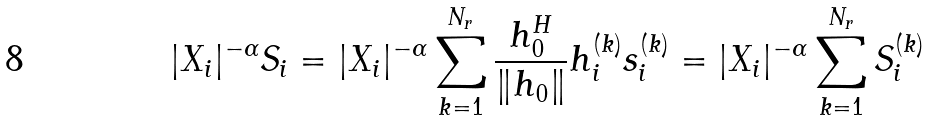<formula> <loc_0><loc_0><loc_500><loc_500>| X _ { i } | ^ { - \alpha } S _ { i } = | X _ { i } | ^ { - \alpha } \sum ^ { N _ { r } } _ { k = 1 } \frac { h _ { 0 } ^ { H } } { \| h _ { 0 } \| } h ^ { ( k ) } _ { i } s ^ { ( k ) } _ { i } = | X _ { i } | ^ { - \alpha } \sum ^ { N _ { r } } _ { k = 1 } S ^ { ( k ) } _ { i }</formula> 